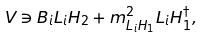Convert formula to latex. <formula><loc_0><loc_0><loc_500><loc_500>V \ni B _ { i } L _ { i } H _ { 2 } + m ^ { 2 } _ { L _ { i } H _ { 1 } } L _ { i } H _ { 1 } ^ { \dagger } ,</formula> 